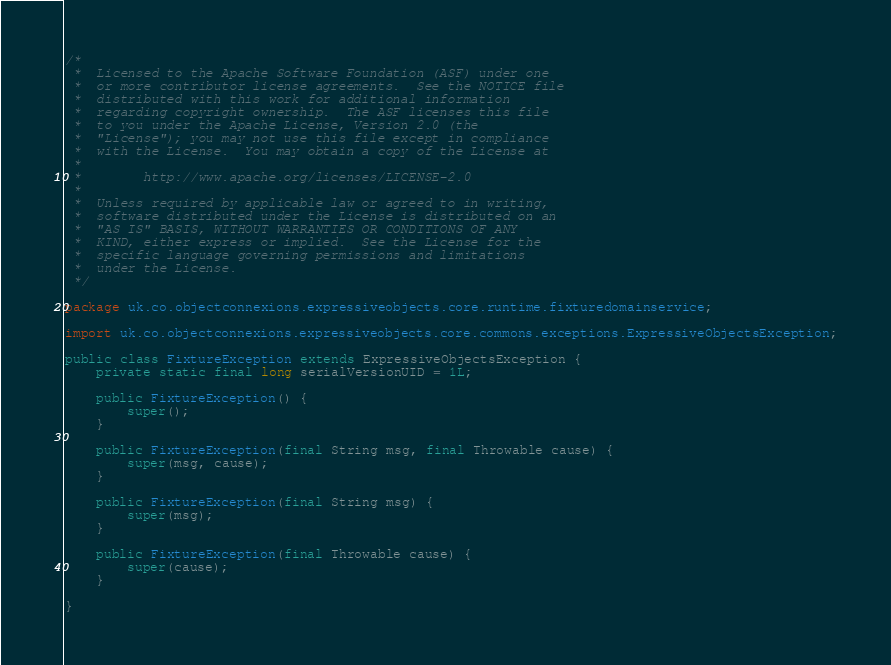Convert code to text. <code><loc_0><loc_0><loc_500><loc_500><_Java_>/*
 *  Licensed to the Apache Software Foundation (ASF) under one
 *  or more contributor license agreements.  See the NOTICE file
 *  distributed with this work for additional information
 *  regarding copyright ownership.  The ASF licenses this file
 *  to you under the Apache License, Version 2.0 (the
 *  "License"); you may not use this file except in compliance
 *  with the License.  You may obtain a copy of the License at
 *
 *        http://www.apache.org/licenses/LICENSE-2.0
 *
 *  Unless required by applicable law or agreed to in writing,
 *  software distributed under the License is distributed on an
 *  "AS IS" BASIS, WITHOUT WARRANTIES OR CONDITIONS OF ANY
 *  KIND, either express or implied.  See the License for the
 *  specific language governing permissions and limitations
 *  under the License.
 */

package uk.co.objectconnexions.expressiveobjects.core.runtime.fixturedomainservice;

import uk.co.objectconnexions.expressiveobjects.core.commons.exceptions.ExpressiveObjectsException;

public class FixtureException extends ExpressiveObjectsException {
    private static final long serialVersionUID = 1L;

    public FixtureException() {
        super();
    }

    public FixtureException(final String msg, final Throwable cause) {
        super(msg, cause);
    }

    public FixtureException(final String msg) {
        super(msg);
    }

    public FixtureException(final Throwable cause) {
        super(cause);
    }

}
</code> 